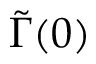<formula> <loc_0><loc_0><loc_500><loc_500>\widetilde { \Gamma } ( 0 )</formula> 